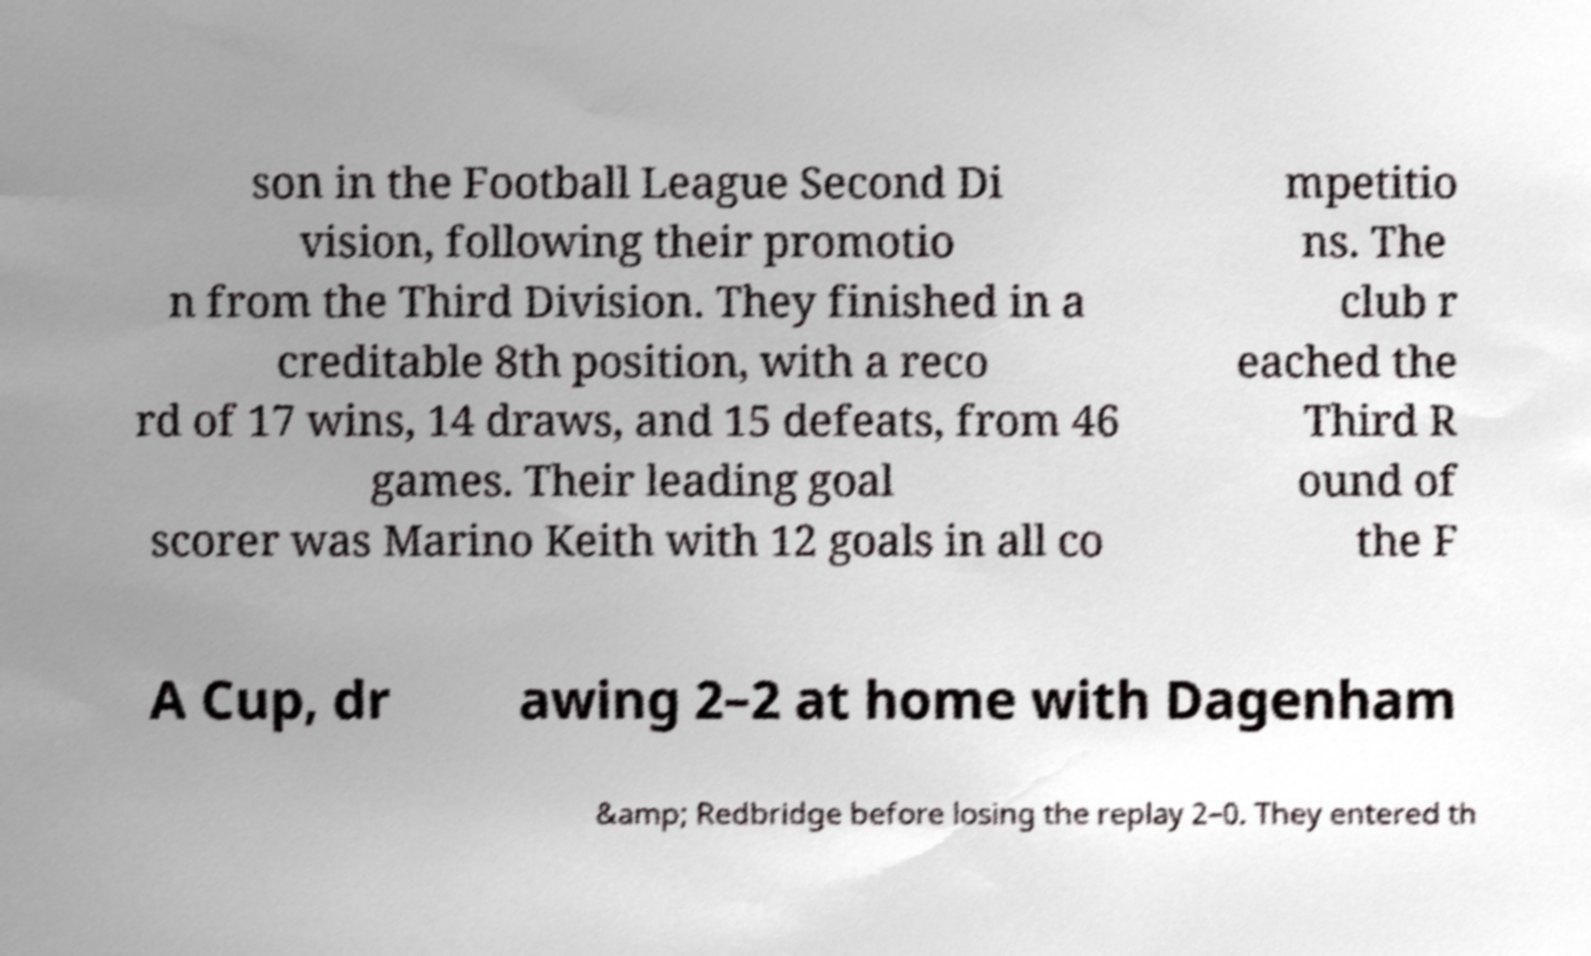What messages or text are displayed in this image? I need them in a readable, typed format. son in the Football League Second Di vision, following their promotio n from the Third Division. They finished in a creditable 8th position, with a reco rd of 17 wins, 14 draws, and 15 defeats, from 46 games. Their leading goal scorer was Marino Keith with 12 goals in all co mpetitio ns. The club r eached the Third R ound of the F A Cup, dr awing 2–2 at home with Dagenham &amp; Redbridge before losing the replay 2–0. They entered th 